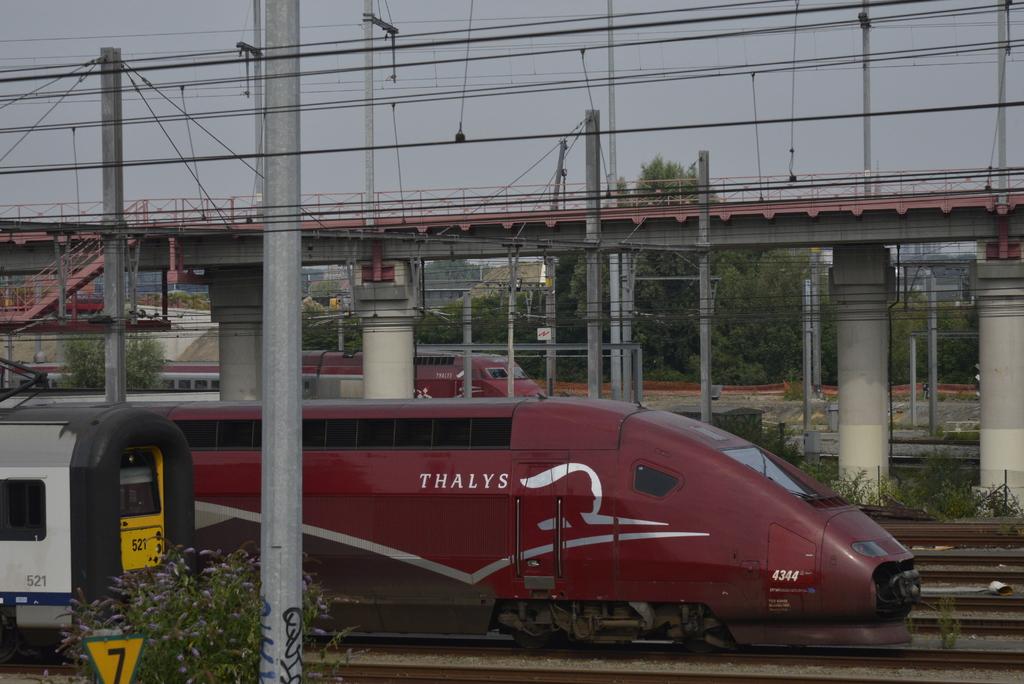Which company operate this train?
Offer a very short reply. Thalys. What is the number of the thalys train?
Your answer should be compact. 4344. 